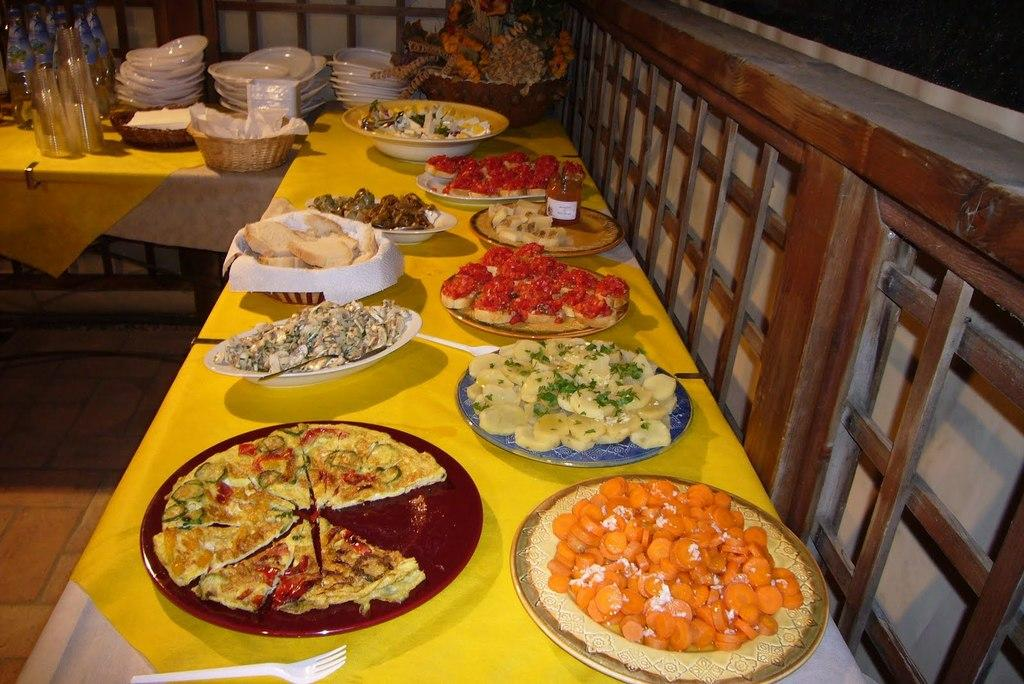What type of items can be seen on the table in the image? There are food items, plates, tissues, baskets, and glasses visible on the table in the image. What other objects are arranged on the table? There are other objects arranged on the table, but their specific details are not mentioned in the provided facts. What is the material of the wall beside the table? The wall beside the table is made of wood. Can you see a fan in the image? There is no fan present in the image. Is there a cannon on the table in the image? There is no cannon present in the image. 